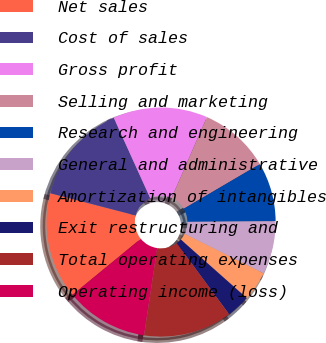Convert chart. <chart><loc_0><loc_0><loc_500><loc_500><pie_chart><fcel>Net sales<fcel>Cost of sales<fcel>Gross profit<fcel>Selling and marketing<fcel>Research and engineering<fcel>General and administrative<fcel>Amortization of intangibles<fcel>Exit restructuring and<fcel>Total operating expenses<fcel>Operating income (loss)<nl><fcel>15.0%<fcel>14.17%<fcel>13.33%<fcel>10.0%<fcel>8.33%<fcel>7.5%<fcel>4.17%<fcel>3.33%<fcel>12.5%<fcel>11.67%<nl></chart> 